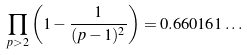<formula> <loc_0><loc_0><loc_500><loc_500>\prod _ { p > 2 } \left ( 1 - { \frac { 1 } { ( p - 1 ) ^ { 2 } } } \right ) = 0 . 6 6 0 1 6 1 \dots</formula> 